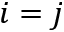Convert formula to latex. <formula><loc_0><loc_0><loc_500><loc_500>i = j</formula> 